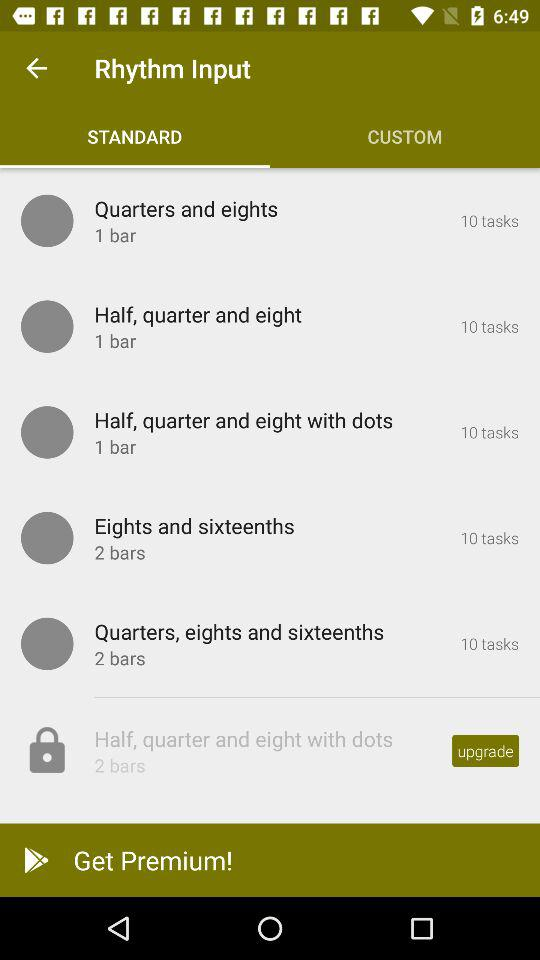What is the standard option that is locked? The standard option that is locked is "Half, quarter and eight with dots". 